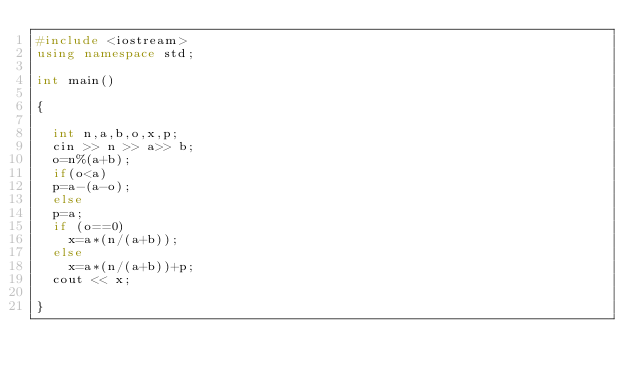Convert code to text. <code><loc_0><loc_0><loc_500><loc_500><_C++_>#include <iostream>
using namespace std;

int main()

{
	
	int n,a,b,o,x,p;
	cin >> n >> a>> b;
	o=n%(a+b);
	if(o<a)
	p=a-(a-o);
	else 
	p=a;
	if (o==0)
		x=a*(n/(a+b));
	else 
		x=a*(n/(a+b))+p;
	cout << x;
	
}
</code> 